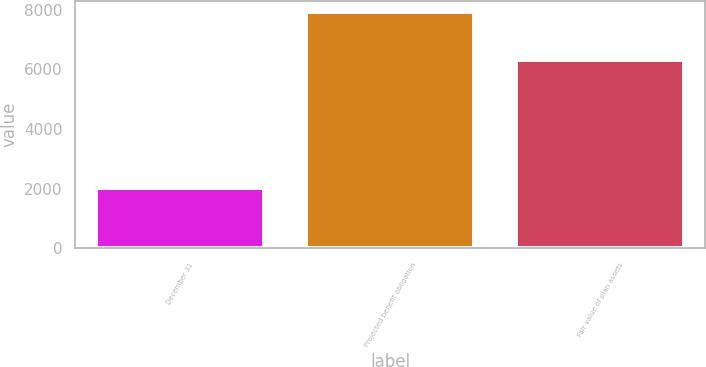Convert chart. <chart><loc_0><loc_0><loc_500><loc_500><bar_chart><fcel>December 31<fcel>Projected benefit obligation<fcel>Fair value of plan assets<nl><fcel>2016<fcel>7907<fcel>6303<nl></chart> 